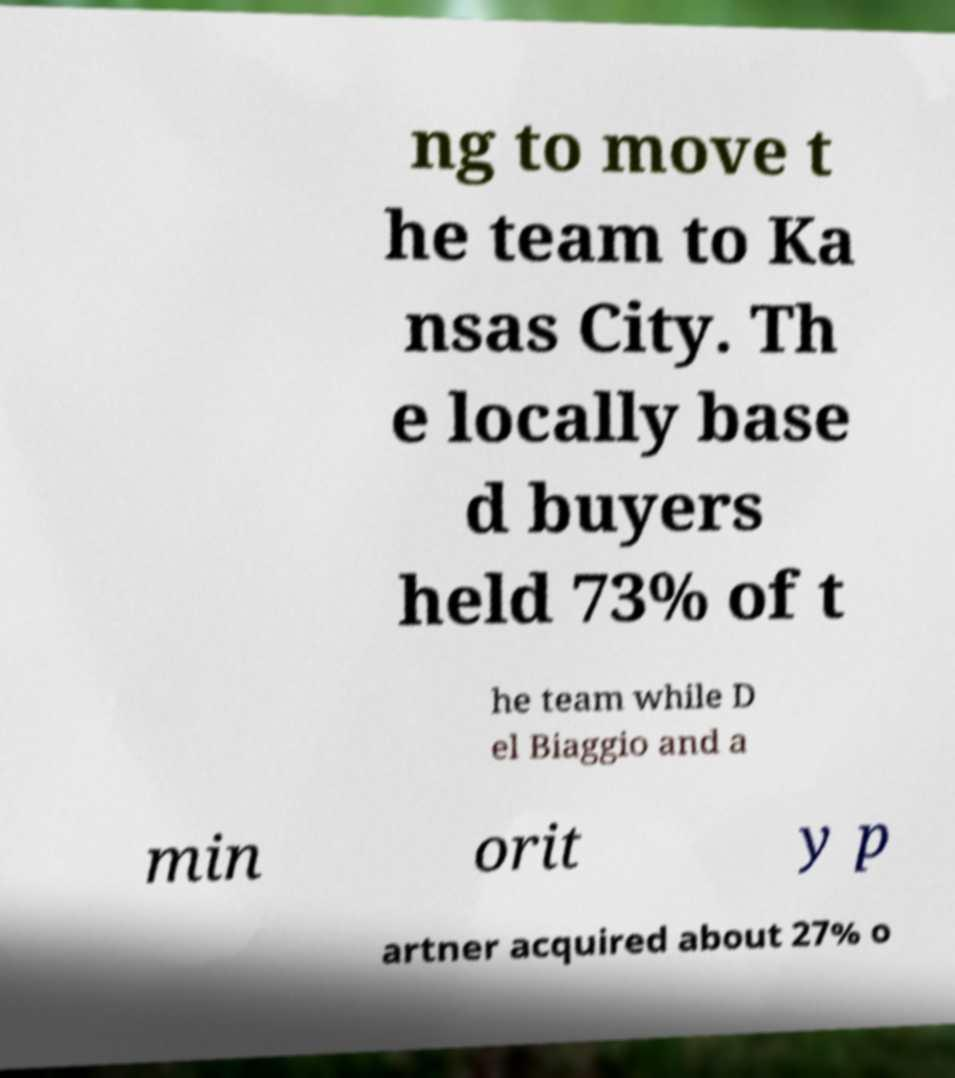Could you extract and type out the text from this image? ng to move t he team to Ka nsas City. Th e locally base d buyers held 73% of t he team while D el Biaggio and a min orit y p artner acquired about 27% o 